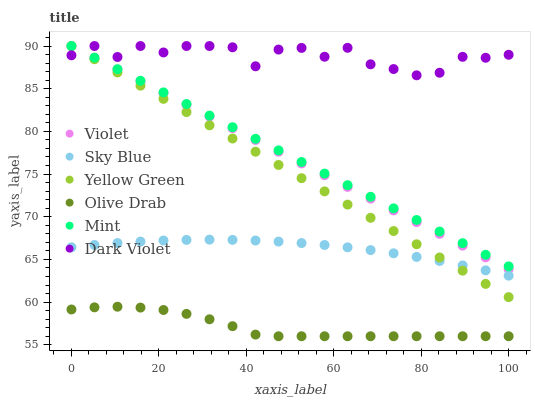Does Olive Drab have the minimum area under the curve?
Answer yes or no. Yes. Does Dark Violet have the maximum area under the curve?
Answer yes or no. Yes. Does Violet have the minimum area under the curve?
Answer yes or no. No. Does Violet have the maximum area under the curve?
Answer yes or no. No. Is Mint the smoothest?
Answer yes or no. Yes. Is Dark Violet the roughest?
Answer yes or no. Yes. Is Violet the smoothest?
Answer yes or no. No. Is Violet the roughest?
Answer yes or no. No. Does Olive Drab have the lowest value?
Answer yes or no. Yes. Does Violet have the lowest value?
Answer yes or no. No. Does Mint have the highest value?
Answer yes or no. Yes. Does Sky Blue have the highest value?
Answer yes or no. No. Is Olive Drab less than Violet?
Answer yes or no. Yes. Is Mint greater than Sky Blue?
Answer yes or no. Yes. Does Dark Violet intersect Violet?
Answer yes or no. Yes. Is Dark Violet less than Violet?
Answer yes or no. No. Is Dark Violet greater than Violet?
Answer yes or no. No. Does Olive Drab intersect Violet?
Answer yes or no. No. 